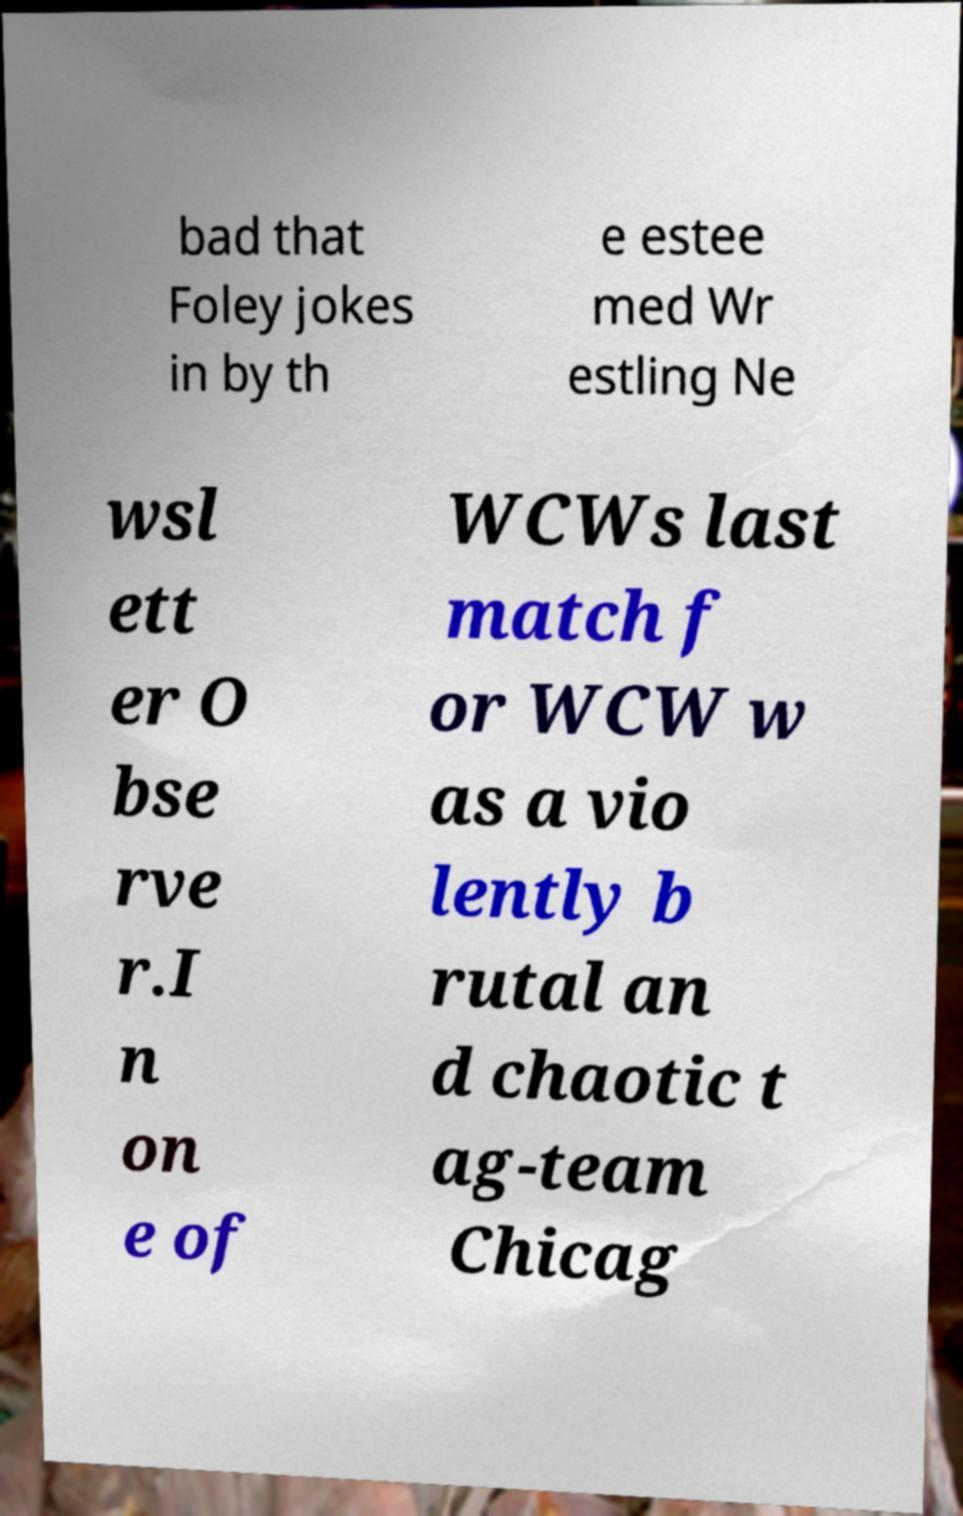Could you assist in decoding the text presented in this image and type it out clearly? bad that Foley jokes in by th e estee med Wr estling Ne wsl ett er O bse rve r.I n on e of WCWs last match f or WCW w as a vio lently b rutal an d chaotic t ag-team Chicag 